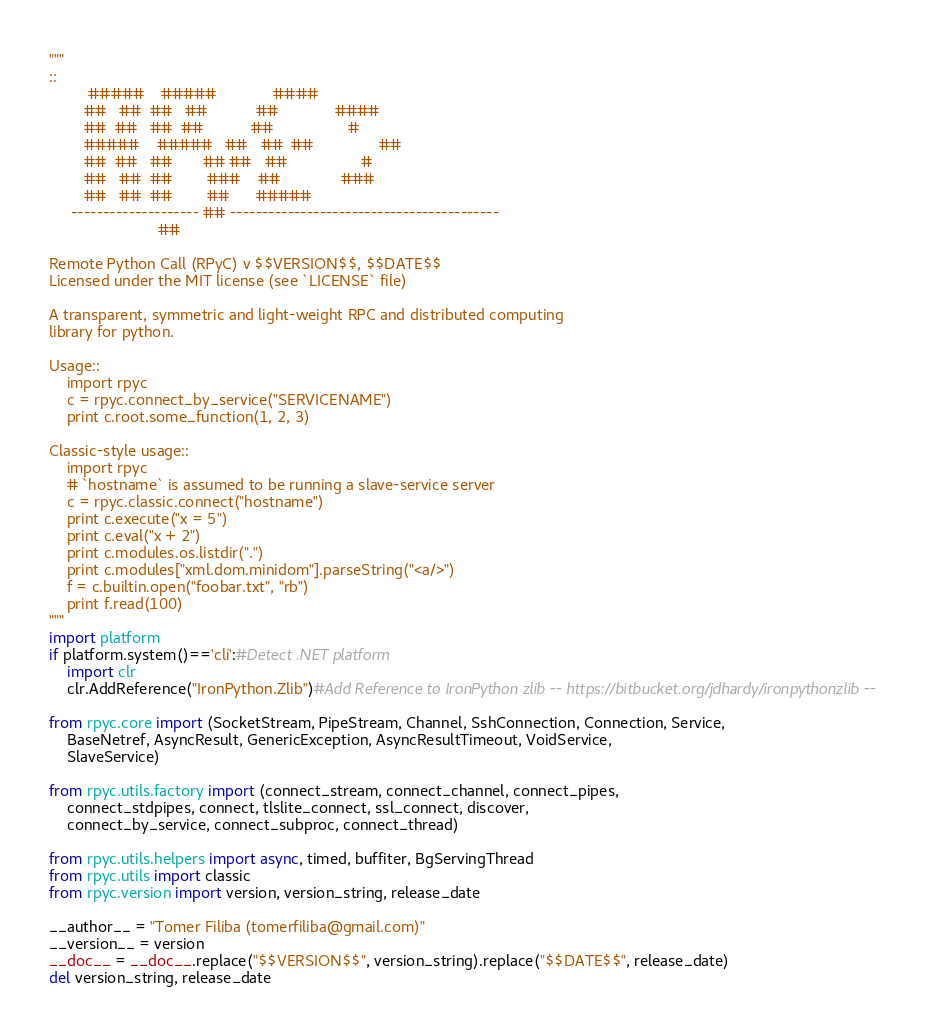<code> <loc_0><loc_0><loc_500><loc_500><_Python_>"""
::
         #####    #####             ####
        ##   ##  ##   ##           ##             ####      
        ##  ##   ##  ##           ##                 #
        #####    #####   ##   ##  ##               ## 
        ##  ##   ##       ## ##   ##                 #
        ##   ##  ##        ###    ##              ###
        ##   ##  ##        ##      #####         
     -------------------- ## ------------------------------------------
                         ##

Remote Python Call (RPyC) v $$VERSION$$, $$DATE$$
Licensed under the MIT license (see `LICENSE` file)

A transparent, symmetric and light-weight RPC and distributed computing 
library for python.

Usage::
    import rpyc
    c = rpyc.connect_by_service("SERVICENAME")
    print c.root.some_function(1, 2, 3)

Classic-style usage::
    import rpyc
    # `hostname` is assumed to be running a slave-service server
    c = rpyc.classic.connect("hostname") 
    print c.execute("x = 5")
    print c.eval("x + 2")
    print c.modules.os.listdir(".")
    print c.modules["xml.dom.minidom"].parseString("<a/>")
    f = c.builtin.open("foobar.txt", "rb")
    print f.read(100)
"""
import platform
if platform.system()=='cli':#Detect .NET platform
	import clr
	clr.AddReference("IronPython.Zlib")#Add Reference to IronPython zlib -- https://bitbucket.org/jdhardy/ironpythonzlib --
	
from rpyc.core import (SocketStream, PipeStream, Channel, SshConnection, Connection, Service,
    BaseNetref, AsyncResult, GenericException, AsyncResultTimeout, VoidService,
    SlaveService)

from rpyc.utils.factory import (connect_stream, connect_channel, connect_pipes, 
    connect_stdpipes, connect, tlslite_connect, ssl_connect, discover, 
    connect_by_service, connect_subproc, connect_thread)

from rpyc.utils.helpers import async, timed, buffiter, BgServingThread
from rpyc.utils import classic
from rpyc.version import version, version_string, release_date

__author__ = "Tomer Filiba (tomerfiliba@gmail.com)"
__version__ = version
__doc__ = __doc__.replace("$$VERSION$$", version_string).replace("$$DATE$$", release_date)
del version_string, release_date

</code> 